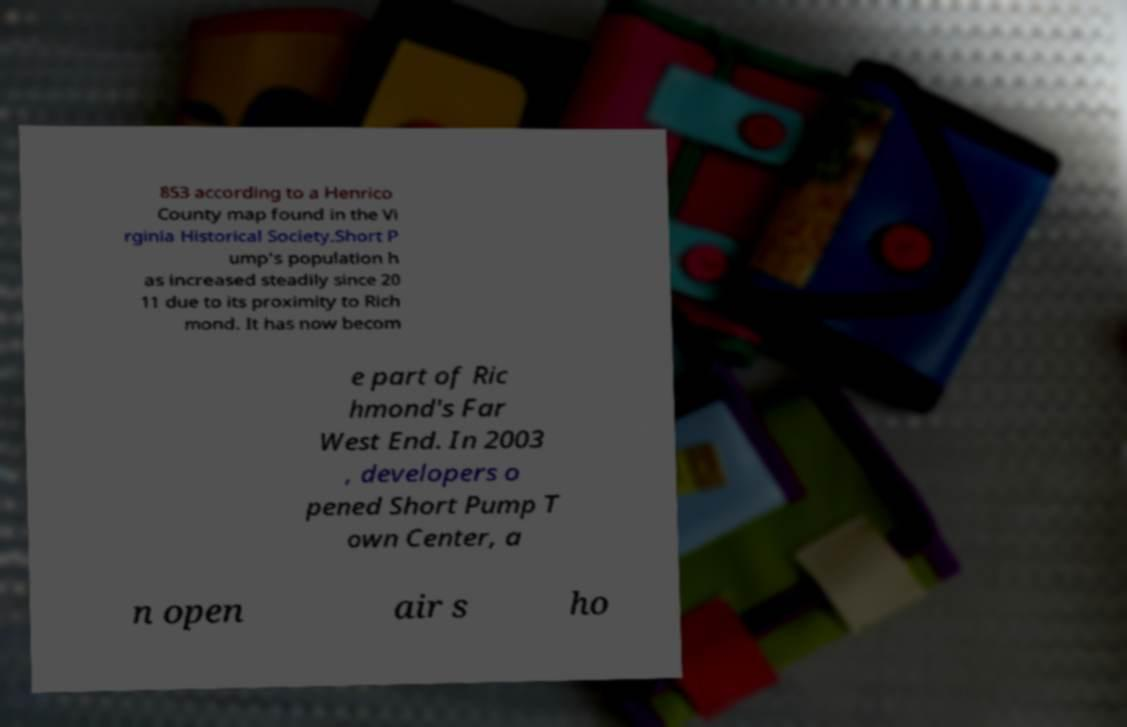Please read and relay the text visible in this image. What does it say? 853 according to a Henrico County map found in the Vi rginia Historical Society.Short P ump's population h as increased steadily since 20 11 due to its proximity to Rich mond. It has now becom e part of Ric hmond's Far West End. In 2003 , developers o pened Short Pump T own Center, a n open air s ho 